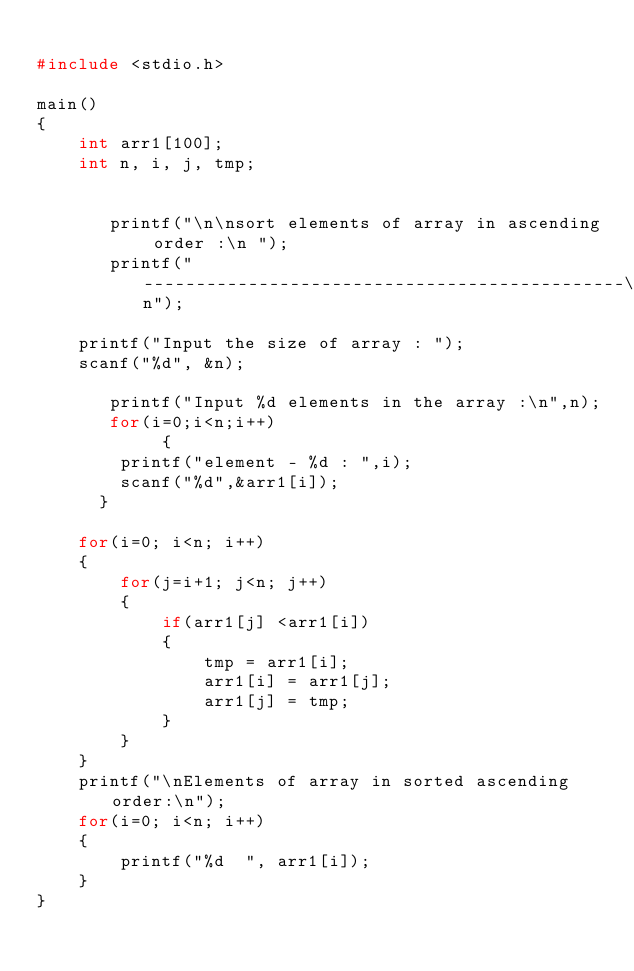<code> <loc_0><loc_0><loc_500><loc_500><_C_>
#include <stdio.h>

main()
{
    int arr1[100];
    int n, i, j, tmp;
	
	
       printf("\n\nsort elements of array in ascending order :\n ");
       printf("----------------------------------------------\n");	

    printf("Input the size of array : ");
    scanf("%d", &n);

       printf("Input %d elements in the array :\n",n);
       for(i=0;i<n;i++)
            {
	      printf("element - %d : ",i);
	      scanf("%d",&arr1[i]);
	    }

    for(i=0; i<n; i++)
    {
        for(j=i+1; j<n; j++)
        {
            if(arr1[j] <arr1[i])
            {
                tmp = arr1[i];
                arr1[i] = arr1[j];
                arr1[j] = tmp;
            }
        }
    }
    printf("\nElements of array in sorted ascending order:\n");
    for(i=0; i<n; i++)
    {
        printf("%d  ", arr1[i]);
    }
}
	       </code> 